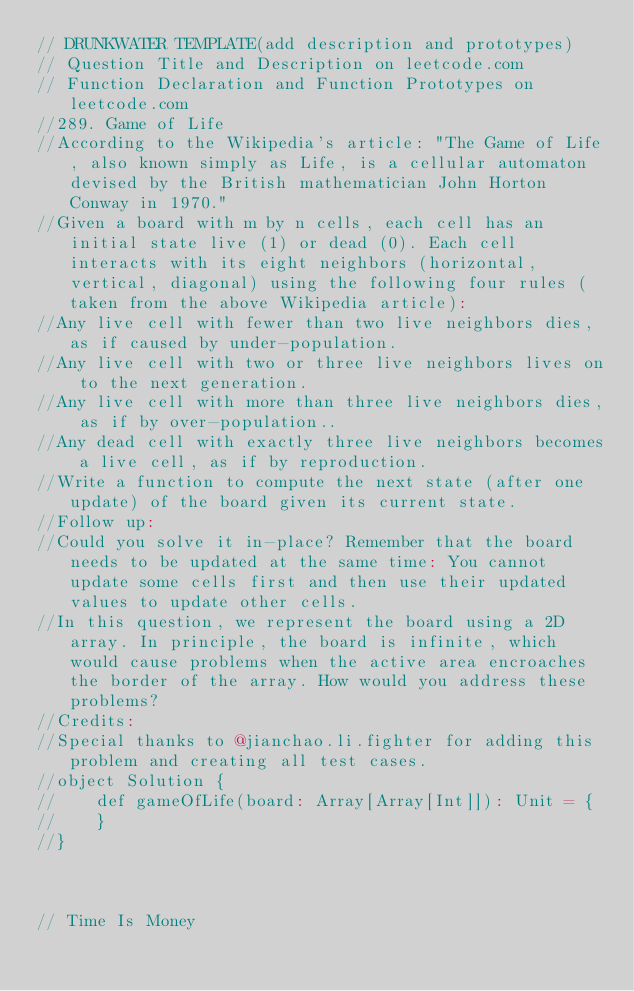<code> <loc_0><loc_0><loc_500><loc_500><_Scala_>// DRUNKWATER TEMPLATE(add description and prototypes)
// Question Title and Description on leetcode.com
// Function Declaration and Function Prototypes on leetcode.com
//289. Game of Life
//According to the Wikipedia's article: "The Game of Life, also known simply as Life, is a cellular automaton devised by the British mathematician John Horton Conway in 1970."
//Given a board with m by n cells, each cell has an initial state live (1) or dead (0). Each cell interacts with its eight neighbors (horizontal, vertical, diagonal) using the following four rules (taken from the above Wikipedia article):
//Any live cell with fewer than two live neighbors dies, as if caused by under-population.
//Any live cell with two or three live neighbors lives on to the next generation.
//Any live cell with more than three live neighbors dies, as if by over-population..
//Any dead cell with exactly three live neighbors becomes a live cell, as if by reproduction.
//Write a function to compute the next state (after one update) of the board given its current state.
//Follow up:
//Could you solve it in-place? Remember that the board needs to be updated at the same time: You cannot update some cells first and then use their updated values to update other cells.
//In this question, we represent the board using a 2D array. In principle, the board is infinite, which would cause problems when the active area encroaches the border of the array. How would you address these problems?
//Credits:
//Special thanks to @jianchao.li.fighter for adding this problem and creating all test cases.
//object Solution {
//    def gameOfLife(board: Array[Array[Int]]): Unit = {
//    }
//}



// Time Is Money</code> 